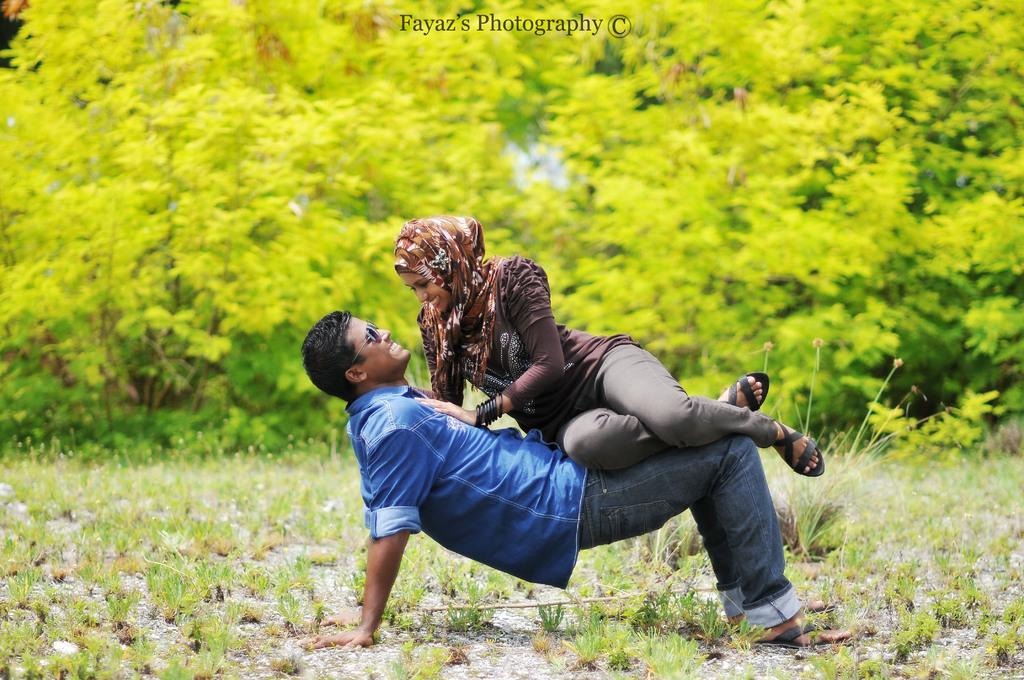How many people are in the image? There are two people in the image, a man and a woman. What is the woman doing in relation to the man? The woman is seated on the man. What expressions do the man and woman have in the image? Both the man and woman are smiling. What can be seen in the background of the image? There are trees visible in the background of the image. What letters are being stitched together by the man in the image? There are no letters or stitching present in the image. How does the woman's digestion affect the man in the image? There is no information about the woman's digestion or its effect on the man in the image. 